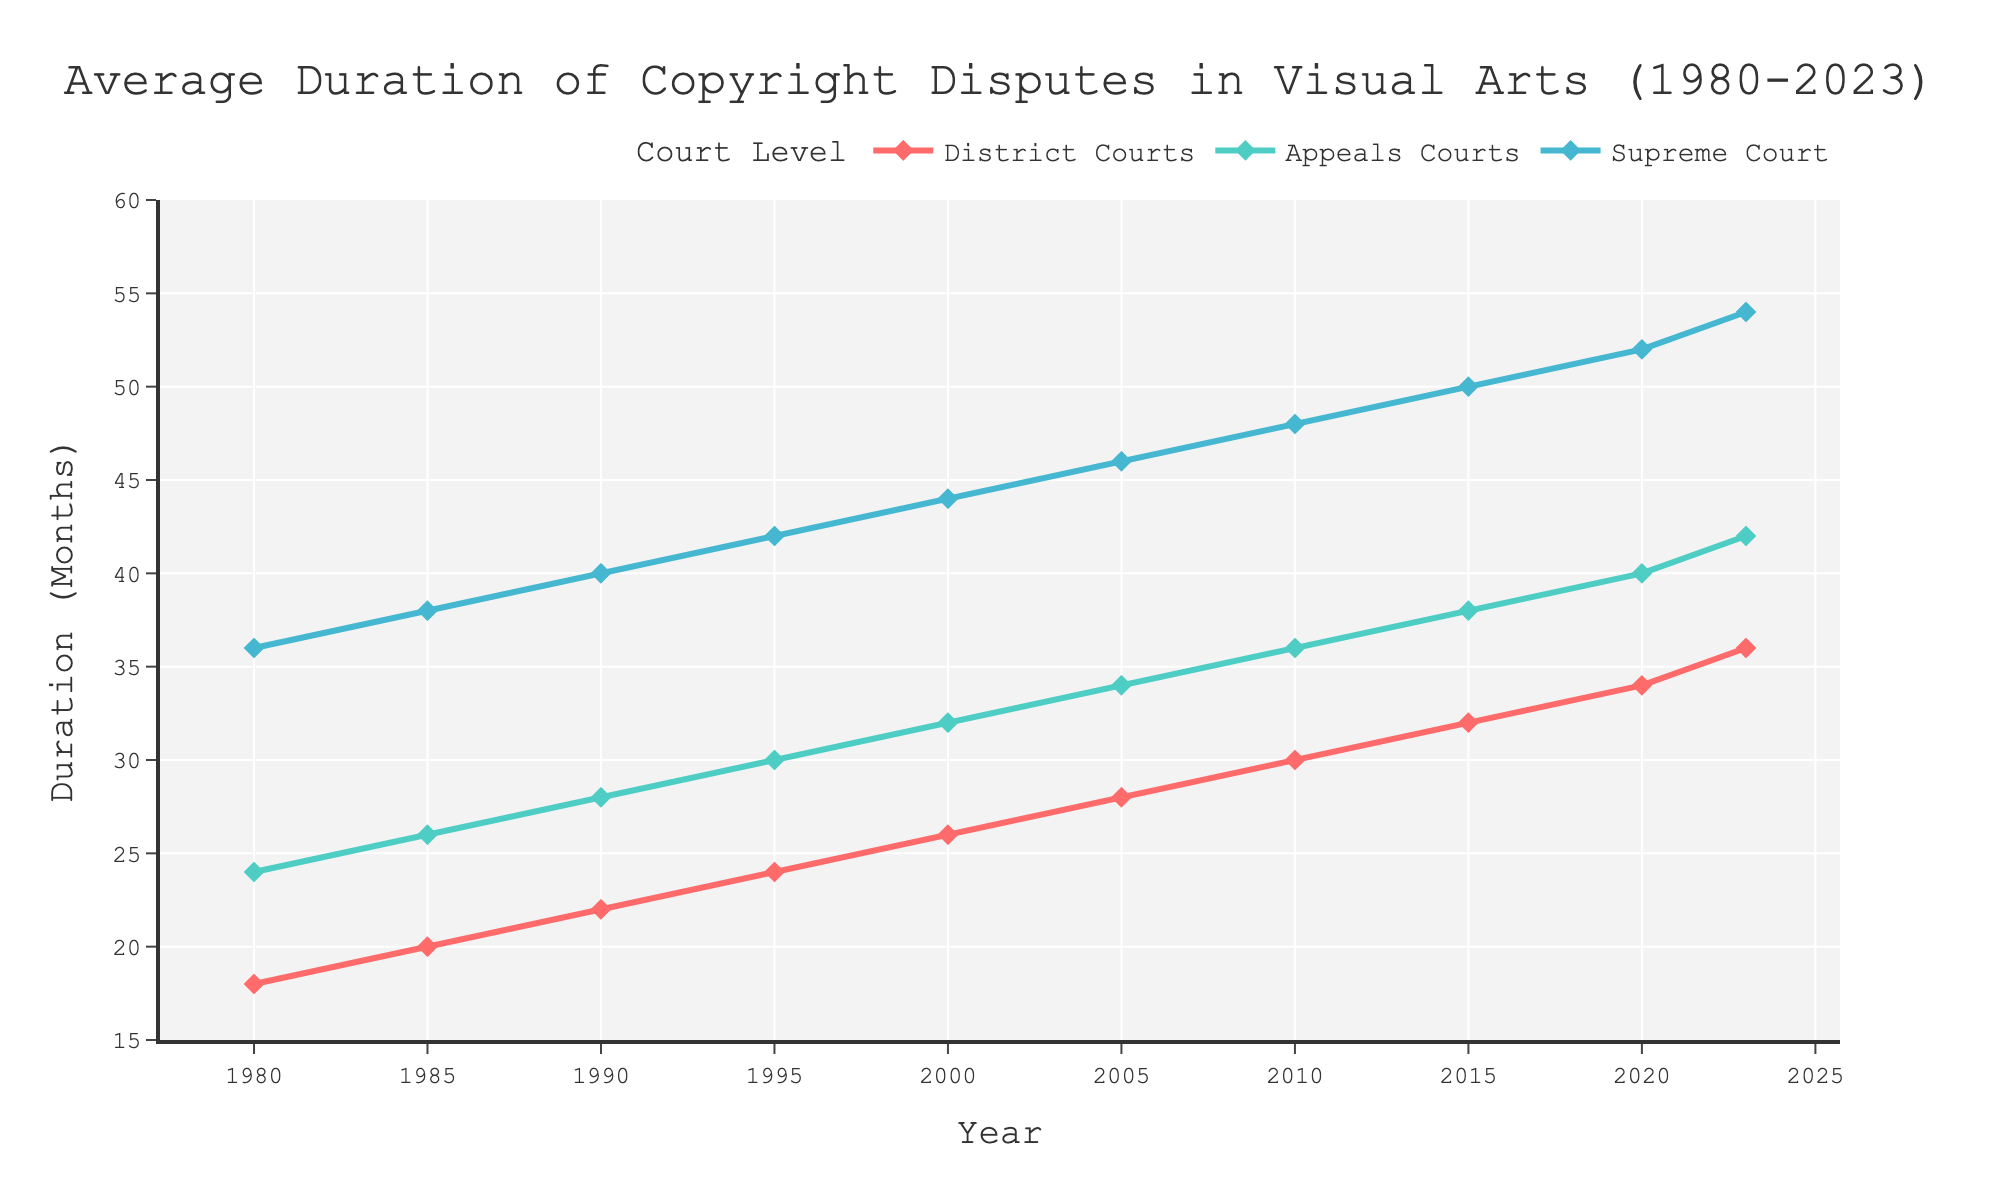what's the average duration of copyright disputes in District Courts for the years 2000, 2005, and 2010? For the years 2000, 2005, and 2010, the durations are 26, 28, and 30 months respectively. The average is (26 + 28 + 30) / 3 = 28 months
Answer: 28 months Which year saw the largest increase in the average duration of copyright disputes in Appeals Courts? We compare the differences between consecutive years for Appeals Courts. The increments are 2 for each period, so no single year has a larger increase than any other; they are all the same
Answer: All years are equal In 1990, were the average durations of copyright disputes longer in District Courts or Appeals Courts? In 1990, the duration in District Courts was 22 months, while in Appeals Courts it was 28 months. Thus, disputes lasted longer in Appeals Courts
Answer: Appeals Courts What was the total duration of copyright disputes in the Supreme Court in the years 2010 and 2023? For 2010 and 2023, the durations in the Supreme Court were 48 and 54 months respectively. The total is 48 + 54 = 102 months
Answer: 102 months By how much has the average duration of copyright disputes in District Courts increased from 1980 to 2023? The duration increased from 18 months in 1980 to 36 months in 2023. The increase is 36 - 18 = 18 months
Answer: 18 months In which year did the difference between the durations of copyright disputes in Appeals Courts and Supreme Court reach the minimum value? We compare the differences for each year. The minimum difference is consistently 12 months across all years (1980: 36-24=12, ... , 2023: 54-42=12), so any year mentioned is correct
Answer: 1980 (or any year, the differences are equal) Which court level had the largest increase in average dispute duration between 1980 and 2023? The differences from 1980 to 2023 are 36-18=18 for District Courts, 42-24=18 for Appeals Courts, and 54-36=18 for the Supreme Court. All levels had equal increases
Answer: All levels, equal What is the trend in the duration of copyright disputes in Supreme Court from 1980 to 2023? The duration in Supreme Court increased steadily from 36 months in 1980 to 54 months in 2023. This indicates a consistent upward trend
Answer: Upward trend 